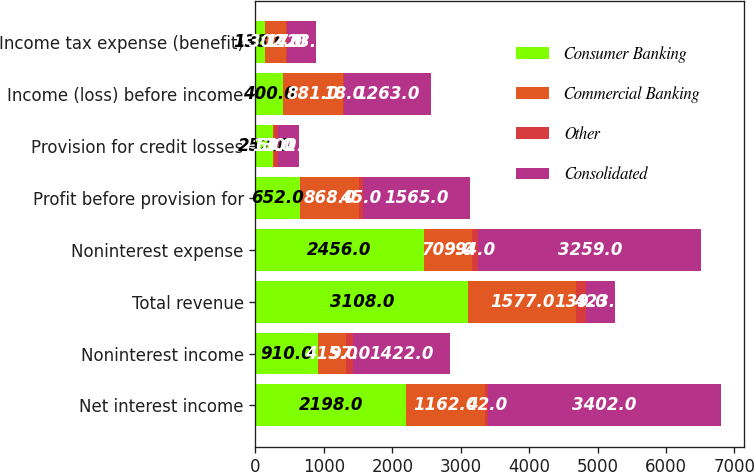<chart> <loc_0><loc_0><loc_500><loc_500><stacked_bar_chart><ecel><fcel>Net interest income<fcel>Noninterest income<fcel>Total revenue<fcel>Noninterest expense<fcel>Profit before provision for<fcel>Provision for credit losses<fcel>Income (loss) before income<fcel>Income tax expense (benefit)<nl><fcel>Consumer Banking<fcel>2198<fcel>910<fcel>3108<fcel>2456<fcel>652<fcel>252<fcel>400<fcel>138<nl><fcel>Commercial Banking<fcel>1162<fcel>415<fcel>1577<fcel>709<fcel>868<fcel>13<fcel>881<fcel>302<nl><fcel>Other<fcel>42<fcel>97<fcel>139<fcel>94<fcel>45<fcel>63<fcel>18<fcel>17<nl><fcel>Consolidated<fcel>3402<fcel>1422<fcel>423<fcel>3259<fcel>1565<fcel>302<fcel>1263<fcel>423<nl></chart> 